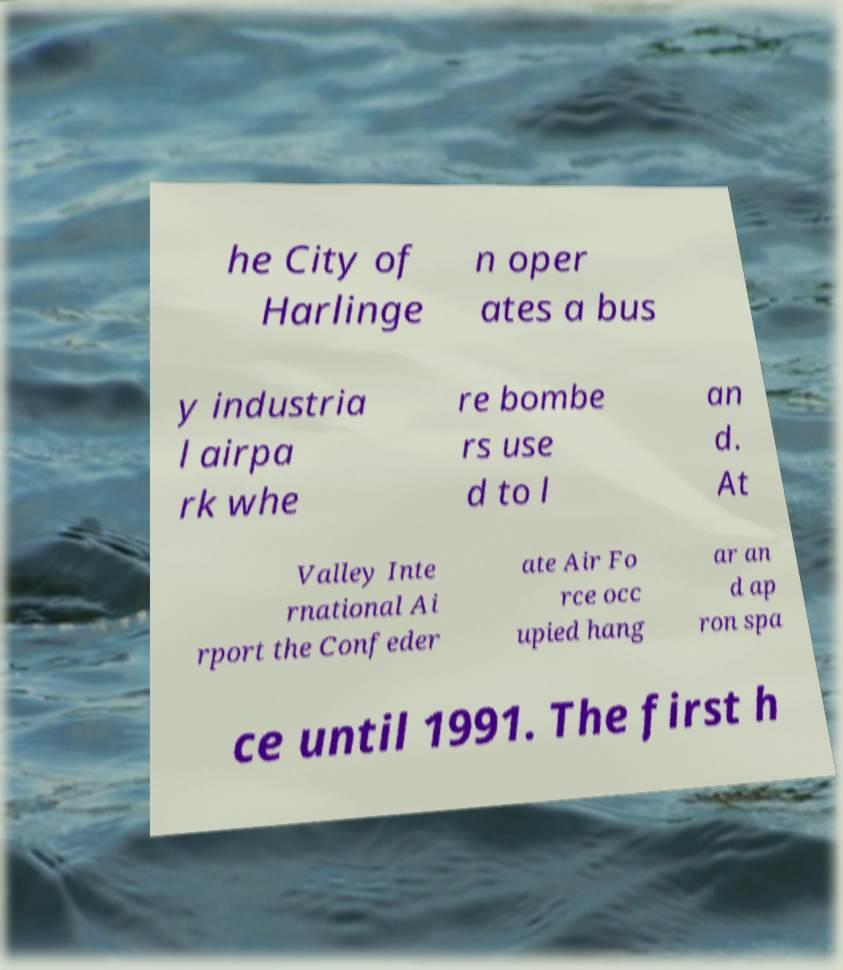Please identify and transcribe the text found in this image. he City of Harlinge n oper ates a bus y industria l airpa rk whe re bombe rs use d to l an d. At Valley Inte rnational Ai rport the Confeder ate Air Fo rce occ upied hang ar an d ap ron spa ce until 1991. The first h 